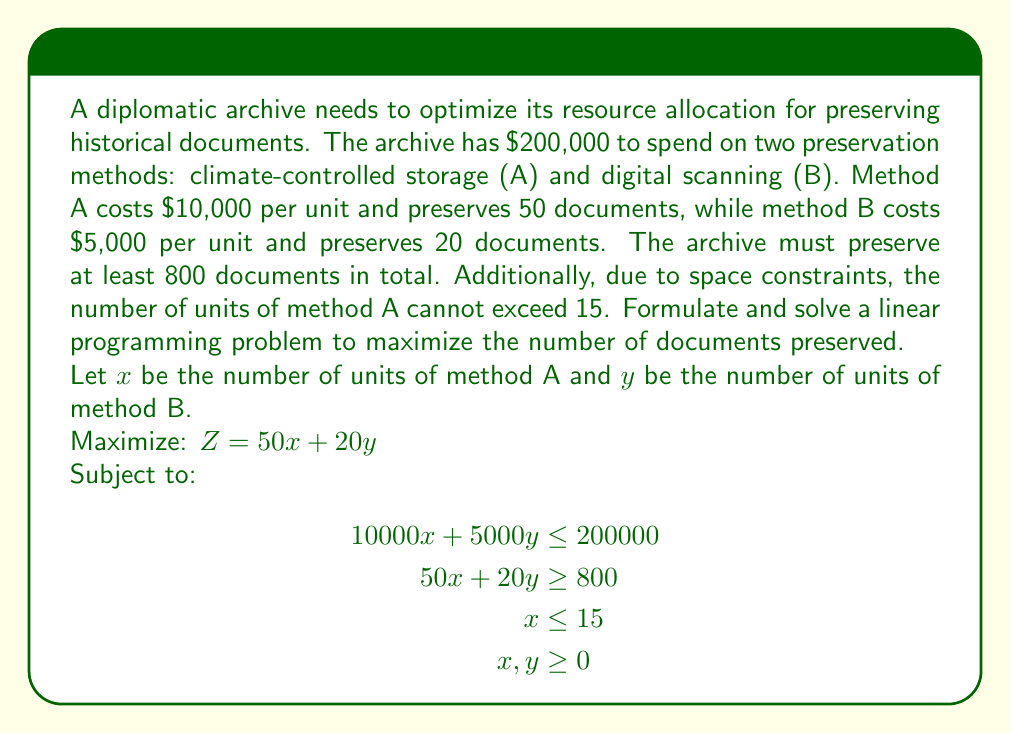Solve this math problem. To solve this linear programming problem, we'll use the graphical method:

1. Plot the constraints:
   a. Budget constraint: $10000x + 5000y = 200000$ or $y = 40 - 2x$
   b. Minimum documents: $50x + 20y = 800$ or $y = 40 - 2.5x$
   c. Space constraint: $x = 15$

2. Identify the feasible region:
   The feasible region is bounded by these constraints and the non-negativity constraints $(x \geq 0, y \geq 0)$.

3. Find the corner points of the feasible region:
   a. $(0, 40)$
   b. $(15, 10)$
   c. $(16, 0)$ (infeasible due to space constraint)
   d. $(15, 0)$

4. Evaluate the objective function at each feasible corner point:
   a. $Z(0, 40) = 50(0) + 20(40) = 800$
   b. $Z(15, 10) = 50(15) + 20(10) = 950$
   c. $Z(15, 0) = 50(15) + 20(0) = 750$

5. The maximum value of Z occurs at the point $(15, 10)$, giving 950 preserved documents.

6. Solution interpretation:
   The archive should use 15 units of method A (climate-controlled storage) and 10 units of method B (digital scanning).

7. Verification:
   - Total cost: $15 * 10000 + 10 * 5000 = 200000$ (meets budget constraint)
   - Total documents preserved: $15 * 50 + 10 * 20 = 950$ (exceeds minimum requirement)
   - Space constraint for method A is met (15 units)
Answer: The optimal solution is to use 15 units of climate-controlled storage (method A) and 10 units of digital scanning (method B), preserving a total of 950 documents. 